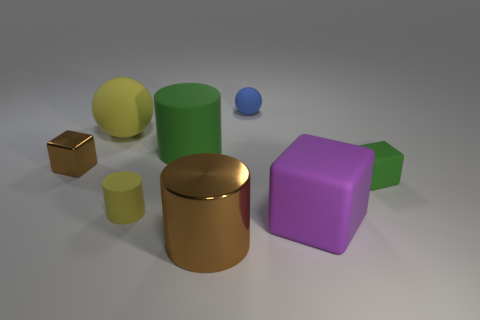How many rubber things are there? There are six objects in the image that appear to be made of materials with rubbery textures, each varying in color and shape, adding visual interest to the scene. 